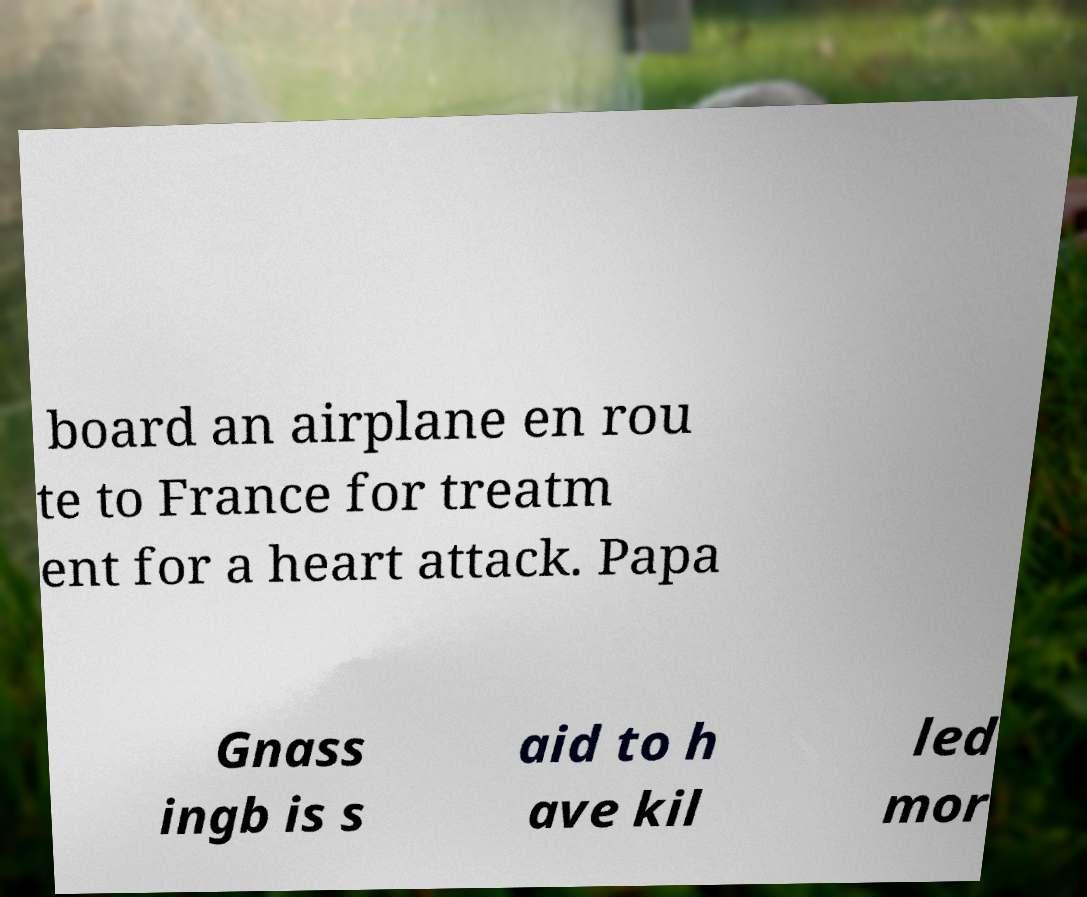Could you assist in decoding the text presented in this image and type it out clearly? board an airplane en rou te to France for treatm ent for a heart attack. Papa Gnass ingb is s aid to h ave kil led mor 